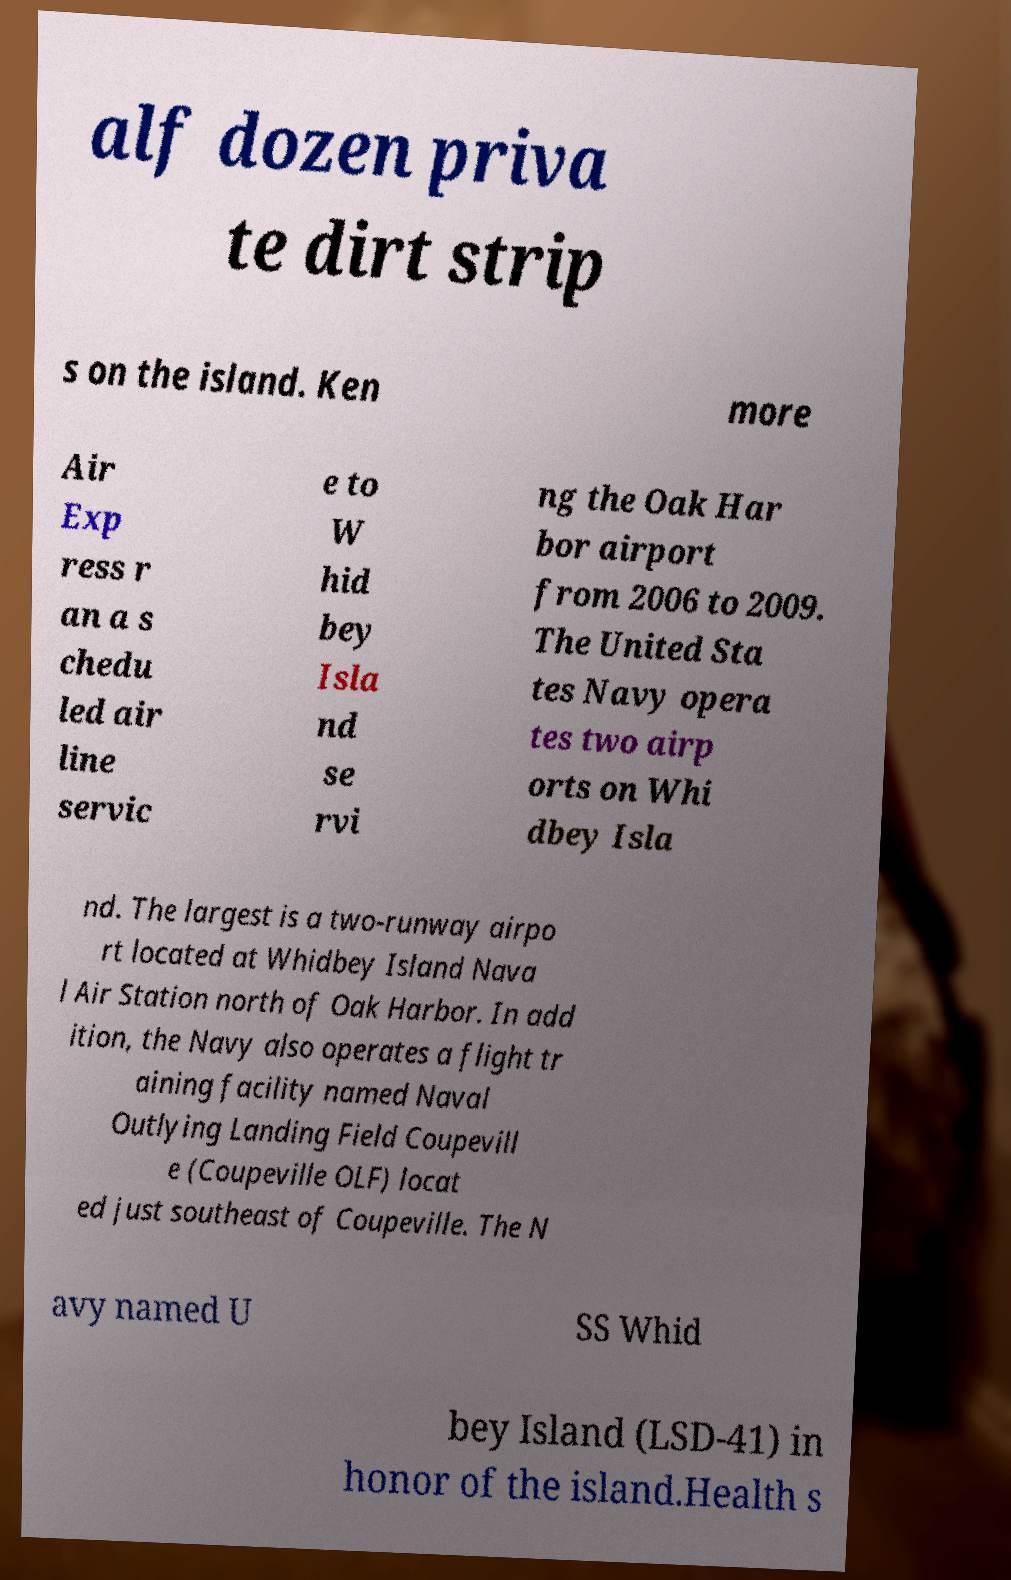Please identify and transcribe the text found in this image. alf dozen priva te dirt strip s on the island. Ken more Air Exp ress r an a s chedu led air line servic e to W hid bey Isla nd se rvi ng the Oak Har bor airport from 2006 to 2009. The United Sta tes Navy opera tes two airp orts on Whi dbey Isla nd. The largest is a two-runway airpo rt located at Whidbey Island Nava l Air Station north of Oak Harbor. In add ition, the Navy also operates a flight tr aining facility named Naval Outlying Landing Field Coupevill e (Coupeville OLF) locat ed just southeast of Coupeville. The N avy named U SS Whid bey Island (LSD-41) in honor of the island.Health s 